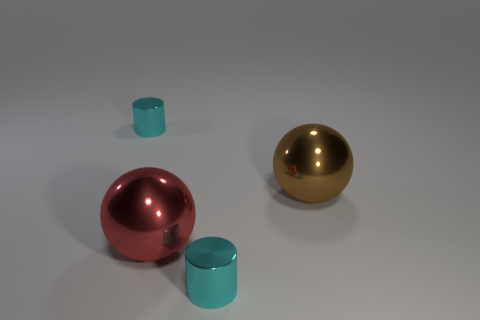How many things are either metallic objects on the left side of the big red shiny ball or tiny cyan cylinders in front of the large red shiny ball?
Your response must be concise. 2. There is a cyan metallic object that is on the left side of the red object; is its size the same as the large brown metal ball?
Your answer should be compact. No. There is a brown thing that is the same shape as the red shiny object; what size is it?
Offer a very short reply. Large. There is a red thing that is the same size as the brown metal thing; what is its material?
Offer a very short reply. Metal. There is a brown object that is the same shape as the big red metal object; what is it made of?
Your response must be concise. Metal. How many other objects are there of the same size as the red shiny ball?
Make the answer very short. 1. What is the shape of the red object?
Offer a terse response. Sphere. What is the color of the object that is in front of the big brown thing and on the right side of the red sphere?
Your response must be concise. Cyan. What is the material of the large brown thing?
Your answer should be very brief. Metal. What is the shape of the cyan metal thing that is behind the large brown sphere?
Provide a succinct answer. Cylinder. 